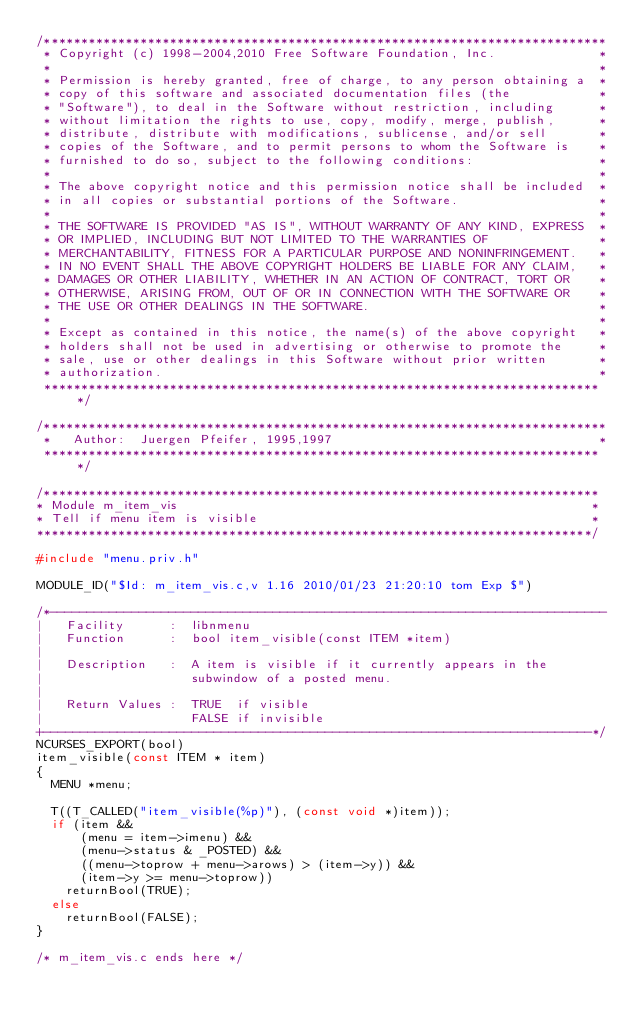Convert code to text. <code><loc_0><loc_0><loc_500><loc_500><_C_>/****************************************************************************
 * Copyright (c) 1998-2004,2010 Free Software Foundation, Inc.              *
 *                                                                          *
 * Permission is hereby granted, free of charge, to any person obtaining a  *
 * copy of this software and associated documentation files (the            *
 * "Software"), to deal in the Software without restriction, including      *
 * without limitation the rights to use, copy, modify, merge, publish,      *
 * distribute, distribute with modifications, sublicense, and/or sell       *
 * copies of the Software, and to permit persons to whom the Software is    *
 * furnished to do so, subject to the following conditions:                 *
 *                                                                          *
 * The above copyright notice and this permission notice shall be included  *
 * in all copies or substantial portions of the Software.                   *
 *                                                                          *
 * THE SOFTWARE IS PROVIDED "AS IS", WITHOUT WARRANTY OF ANY KIND, EXPRESS  *
 * OR IMPLIED, INCLUDING BUT NOT LIMITED TO THE WARRANTIES OF               *
 * MERCHANTABILITY, FITNESS FOR A PARTICULAR PURPOSE AND NONINFRINGEMENT.   *
 * IN NO EVENT SHALL THE ABOVE COPYRIGHT HOLDERS BE LIABLE FOR ANY CLAIM,   *
 * DAMAGES OR OTHER LIABILITY, WHETHER IN AN ACTION OF CONTRACT, TORT OR    *
 * OTHERWISE, ARISING FROM, OUT OF OR IN CONNECTION WITH THE SOFTWARE OR    *
 * THE USE OR OTHER DEALINGS IN THE SOFTWARE.                               *
 *                                                                          *
 * Except as contained in this notice, the name(s) of the above copyright   *
 * holders shall not be used in advertising or otherwise to promote the     *
 * sale, use or other dealings in this Software without prior written       *
 * authorization.                                                           *
 ****************************************************************************/

/****************************************************************************
 *   Author:  Juergen Pfeifer, 1995,1997                                    *
 ****************************************************************************/

/***************************************************************************
* Module m_item_vis                                                        *
* Tell if menu item is visible                                             *
***************************************************************************/

#include "menu.priv.h"

MODULE_ID("$Id: m_item_vis.c,v 1.16 2010/01/23 21:20:10 tom Exp $")

/*---------------------------------------------------------------------------
|   Facility      :  libnmenu  
|   Function      :  bool item_visible(const ITEM *item)
|   
|   Description   :  A item is visible if it currently appears in the
|                    subwindow of a posted menu.
|
|   Return Values :  TRUE  if visible
|                    FALSE if invisible
+--------------------------------------------------------------------------*/
NCURSES_EXPORT(bool)
item_visible(const ITEM * item)
{
  MENU *menu;

  T((T_CALLED("item_visible(%p)"), (const void *)item));
  if (item &&
      (menu = item->imenu) &&
      (menu->status & _POSTED) &&
      ((menu->toprow + menu->arows) > (item->y)) &&
      (item->y >= menu->toprow))
    returnBool(TRUE);
  else
    returnBool(FALSE);
}

/* m_item_vis.c ends here */
</code> 